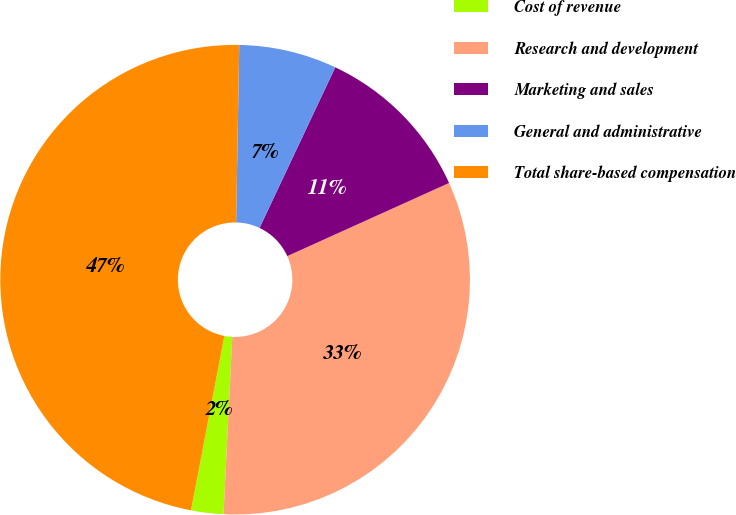<chart> <loc_0><loc_0><loc_500><loc_500><pie_chart><fcel>Cost of revenue<fcel>Research and development<fcel>Marketing and sales<fcel>General and administrative<fcel>Total share-based compensation<nl><fcel>2.22%<fcel>32.54%<fcel>11.23%<fcel>6.73%<fcel>47.27%<nl></chart> 